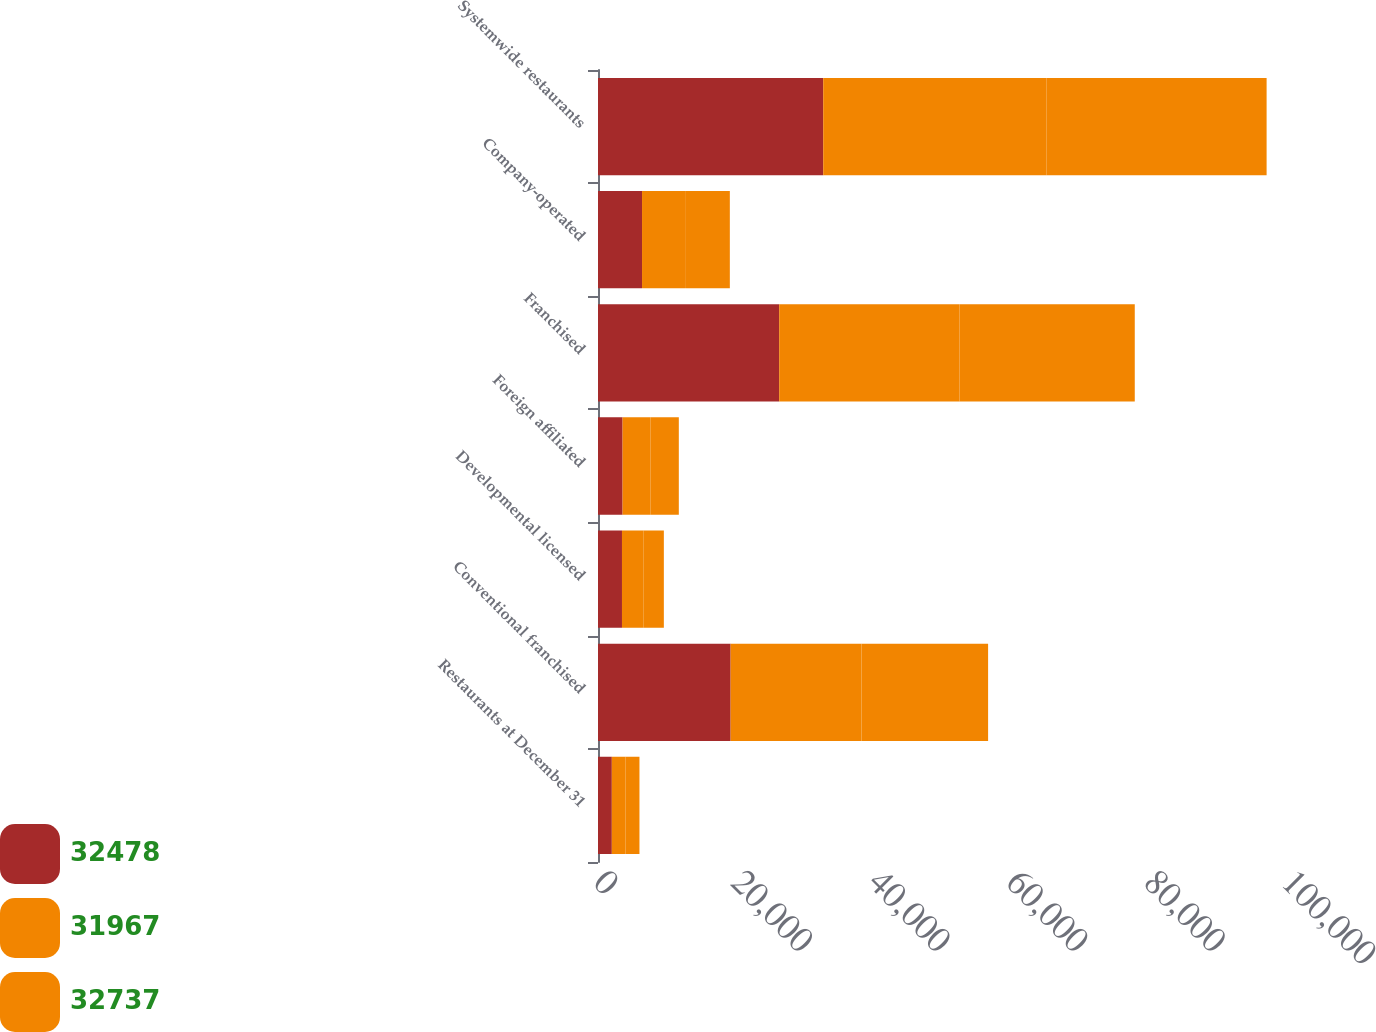Convert chart. <chart><loc_0><loc_0><loc_500><loc_500><stacked_bar_chart><ecel><fcel>Restaurants at December 31<fcel>Conventional franchised<fcel>Developmental licensed<fcel>Foreign affiliated<fcel>Franchised<fcel>Company-operated<fcel>Systemwide restaurants<nl><fcel>32478<fcel>2010<fcel>19279<fcel>3485<fcel>3574<fcel>26338<fcel>6399<fcel>32737<nl><fcel>31967<fcel>2009<fcel>19020<fcel>3160<fcel>4036<fcel>26216<fcel>6262<fcel>32478<nl><fcel>32737<fcel>2008<fcel>18402<fcel>2926<fcel>4137<fcel>25465<fcel>6502<fcel>31967<nl></chart> 